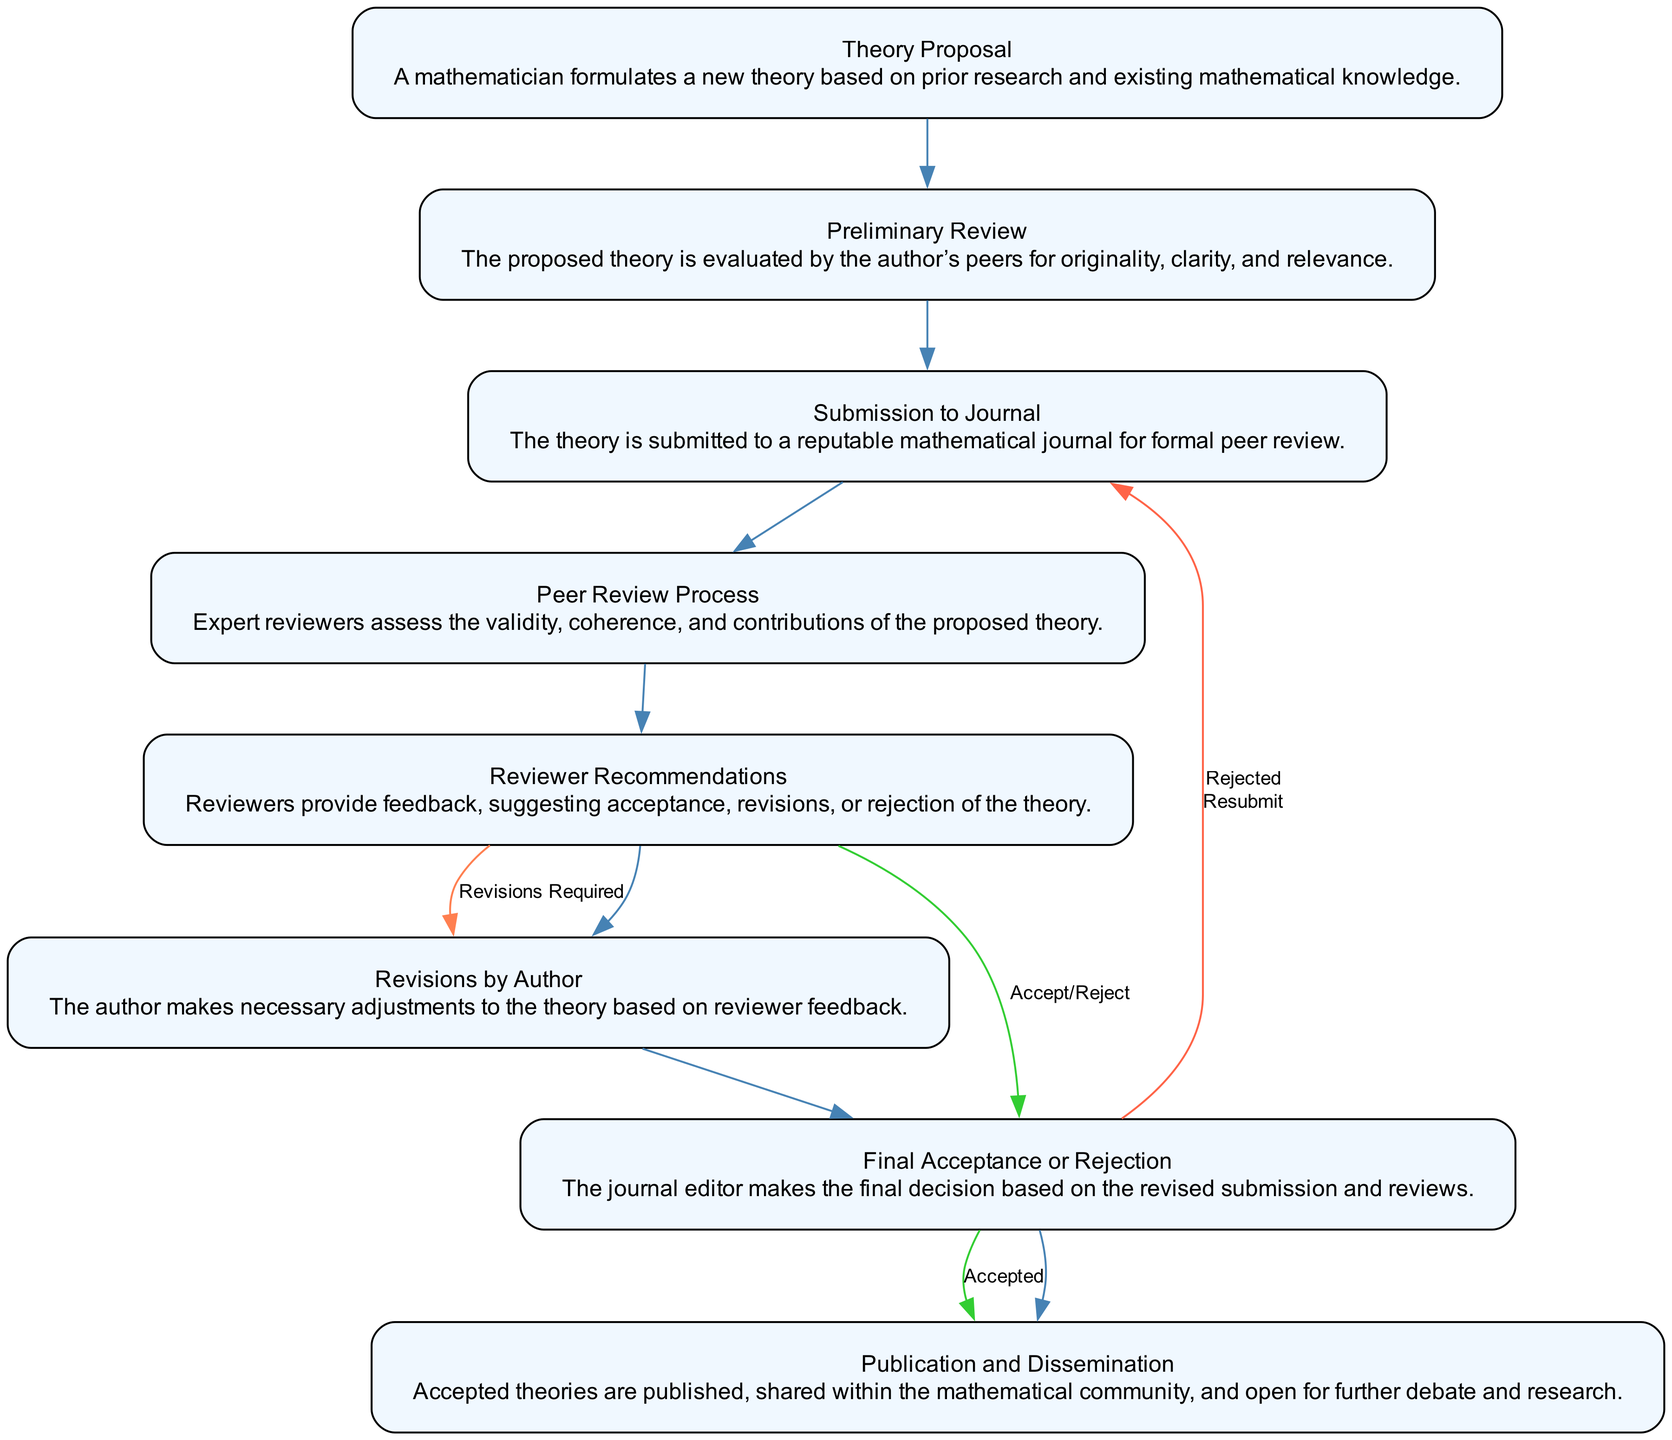What is the first step in the model? The first step is "Theory Proposal," which is where a mathematician formulates a new theory based on prior research and existing mathematical knowledge.
Answer: Theory Proposal How many total nodes are in the diagram? The diagram contains eight nodes, representing distinct steps in the evaluation process.
Answer: Eight What step comes after "Preliminary Review"? The step that follows "Preliminary Review" is "Submission to Journal," indicating the theory is then submitted for formal peer review.
Answer: Submission to Journal What happens if the reviewers recommend revisions? If reviewers recommend revisions, the flow moves to the "Revisions by Author" node, where the author makes necessary adjustments to the theory based on feedback.
Answer: Revisions by Author What are the two possible outcomes after the "Final Acceptance or Rejection"? The two possible outcomes are "Accepted" and "Rejected," with acceptance leading to publication and rejection potentially requiring resubmission.
Answer: Accepted, Rejected Which step requires feedback from expert reviewers? The "Peer Review Process" is the step that involves expert reviewers assessing the validity and contributions of the proposed theory.
Answer: Peer Review Process What is the purpose of the "Publication and Dissemination" step? The purpose is to publish accepted theories, share them with the mathematical community, and allow for further debate and research.
Answer: Publication and Dissemination What color represents revisions required in the flow diagram? The revisions required are represented by an edge labeled in coral color, indicating that the authors need to revise their submission based on reviewer feedback.
Answer: Coral 